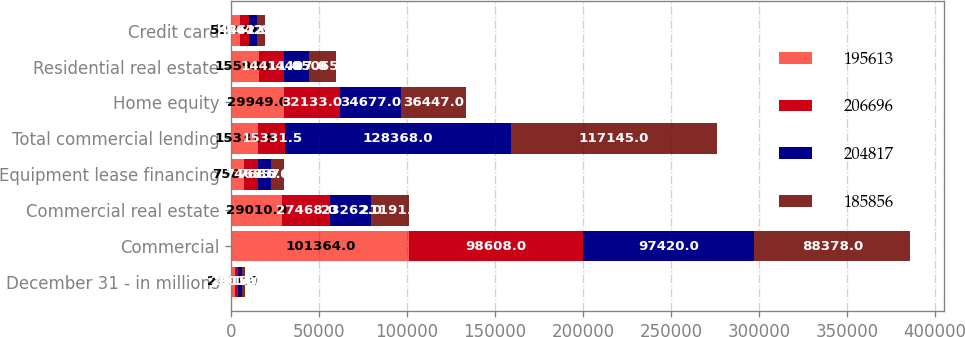Convert chart to OTSL. <chart><loc_0><loc_0><loc_500><loc_500><stacked_bar_chart><ecel><fcel>December 31 - in millions<fcel>Commercial<fcel>Commercial real estate<fcel>Equipment lease financing<fcel>Total commercial lending<fcel>Home equity<fcel>Residential real estate<fcel>Credit card<nl><fcel>195613<fcel>2016<fcel>101364<fcel>29010<fcel>7581<fcel>15331.5<fcel>29949<fcel>15598<fcel>5282<nl><fcel>206696<fcel>2015<fcel>98608<fcel>27468<fcel>7468<fcel>15331.5<fcel>32133<fcel>14411<fcel>4862<nl><fcel>204817<fcel>2014<fcel>97420<fcel>23262<fcel>7686<fcel>128368<fcel>34677<fcel>14407<fcel>4612<nl><fcel>185856<fcel>2013<fcel>88378<fcel>21191<fcel>7576<fcel>117145<fcel>36447<fcel>15065<fcel>4425<nl></chart> 